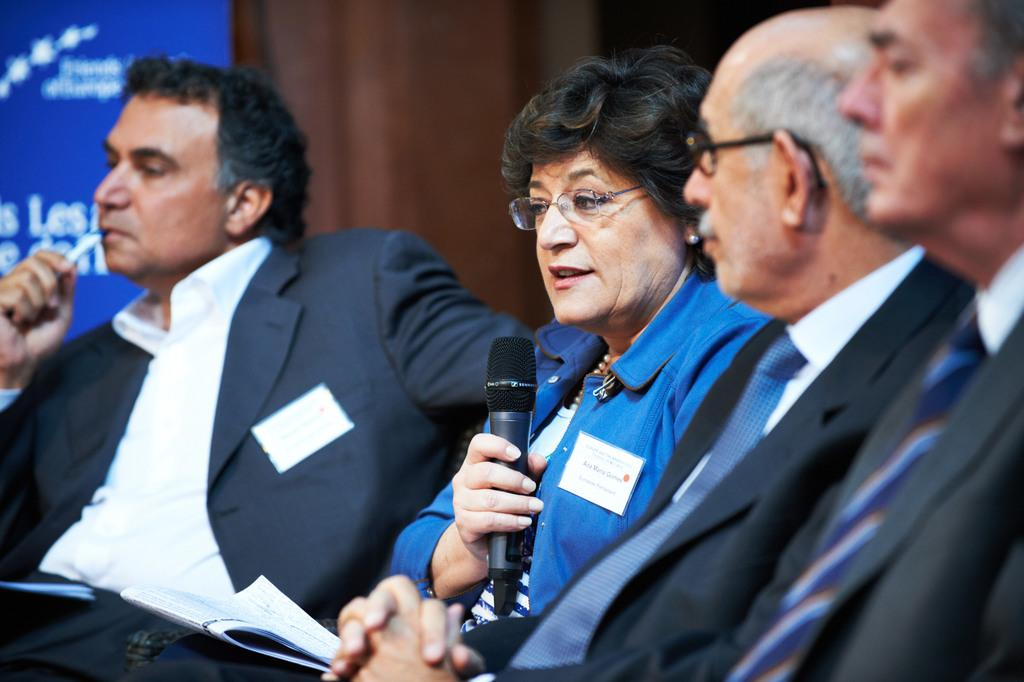How many people are in the image? There is a group of persons in the image. Can you describe the clothing of one of the persons? A woman is wearing blue in the image. What is the woman holding in her hand? The woman is holding a microphone in her hand. What type of rose is the woman holding in the image? There is no rose present in the image; the woman is holding a microphone. How does the kite fly in the image? There is no kite present in the image, so it cannot be determined how it would fly. 